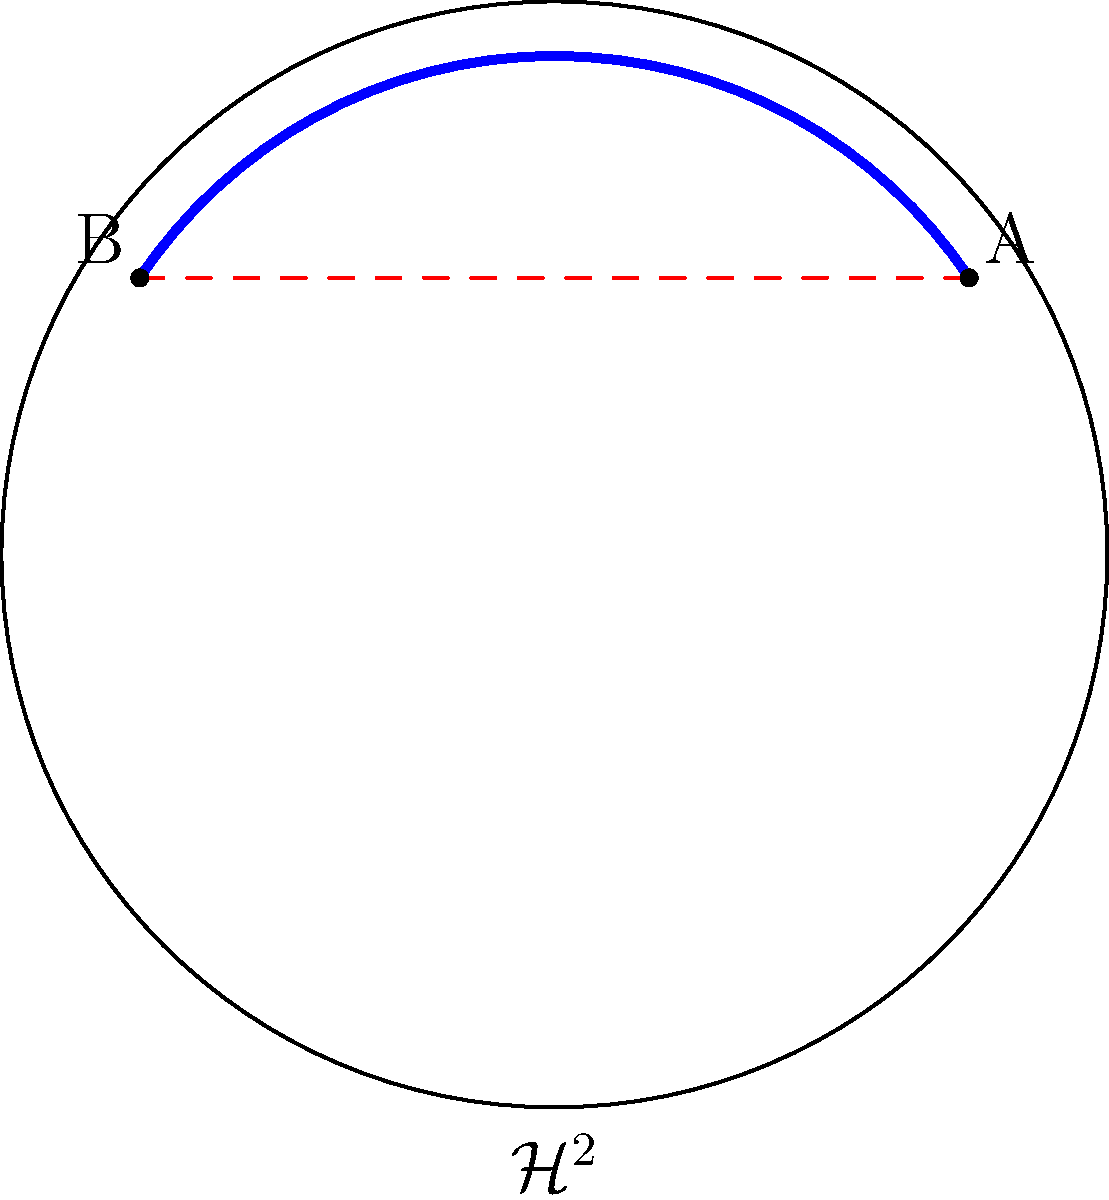In the hyperbolic plane $\mathcal{H}^2$ represented by the Poincaré disk model shown above, consider two points A and B. Which path represents the shortest distance between these points: the blue arc or the red dashed line? Explain your reasoning. To determine the shortest path between two points in hyperbolic geometry, we need to consider the following steps:

1) In Euclidean geometry, the shortest path between two points is always a straight line. However, hyperbolic geometry follows different rules.

2) The Poincaré disk model represents the entire hyperbolic plane as the interior of a circle, where straight lines in hyperbolic geometry are represented by either:
   a) Diameters of the circle
   b) Circular arcs that intersect the boundary circle at right angles

3) In this model, the blue arc is a circular arc that intersects the boundary circle at right angles. This represents a "straight line" in hyperbolic geometry.

4) The red dashed line, while straight in Euclidean geometry, does not represent a straight line in hyperbolic geometry within this model.

5) In hyperbolic geometry, the shortest path between two points is always along a hyperbolic line, which in this case is represented by the blue arc.

6) The red dashed line, although it appears shorter in the Euclidean sense, does not represent a valid path in hyperbolic geometry and would actually be longer if "straightened out" in the hyperbolic plane.

Therefore, the blue arc represents the shortest path between points A and B in the hyperbolic plane.
Answer: The blue arc 